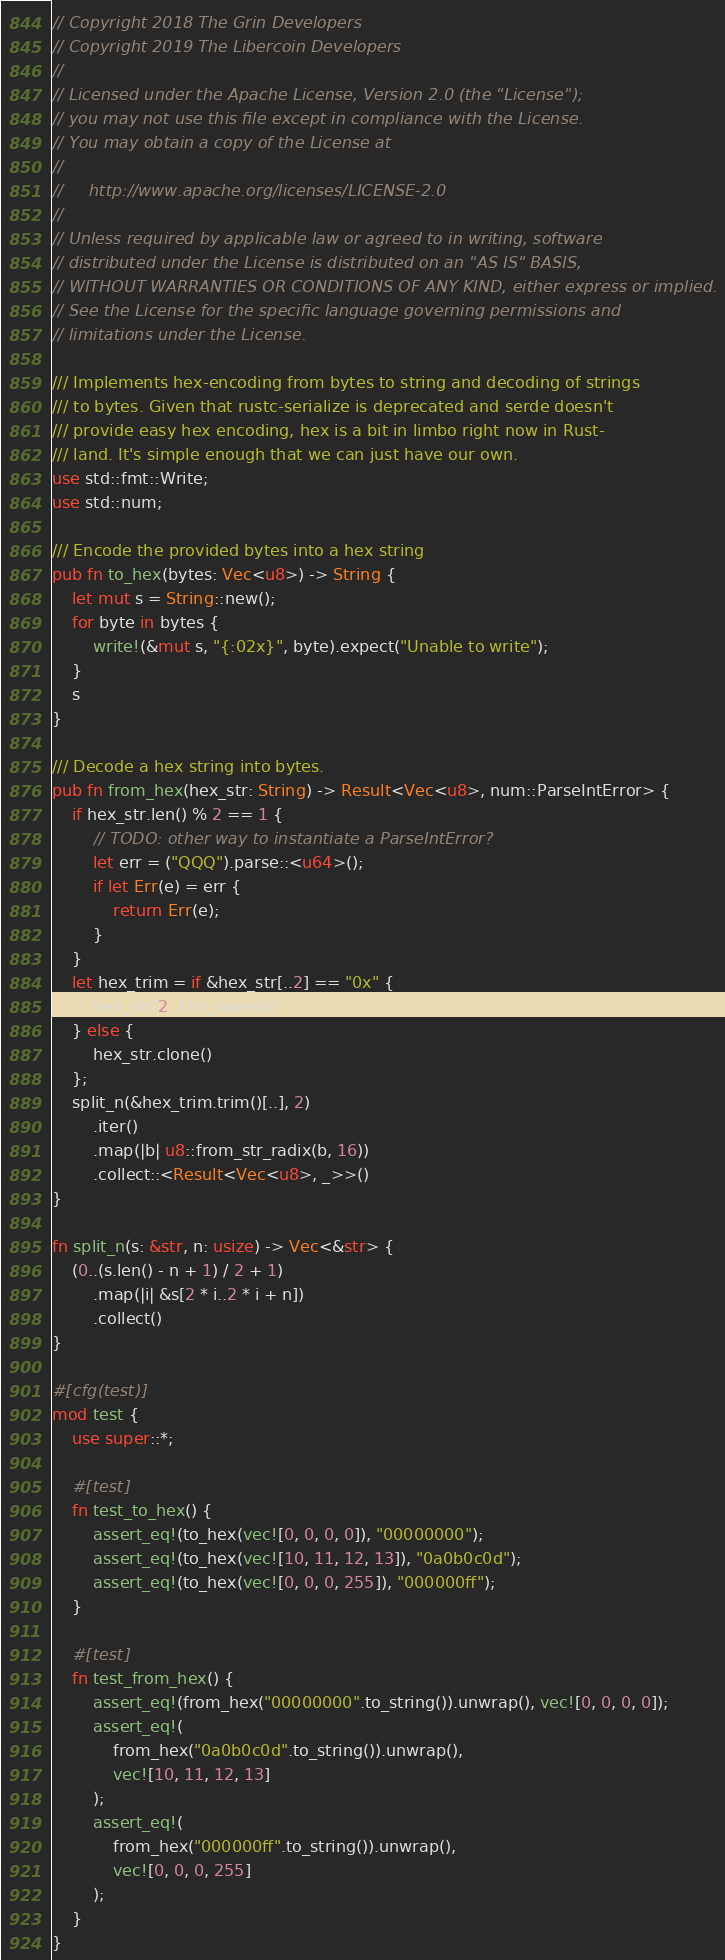<code> <loc_0><loc_0><loc_500><loc_500><_Rust_>// Copyright 2018 The Grin Developers
// Copyright 2019 The Libercoin Developers
//
// Licensed under the Apache License, Version 2.0 (the "License");
// you may not use this file except in compliance with the License.
// You may obtain a copy of the License at
//
//     http://www.apache.org/licenses/LICENSE-2.0
//
// Unless required by applicable law or agreed to in writing, software
// distributed under the License is distributed on an "AS IS" BASIS,
// WITHOUT WARRANTIES OR CONDITIONS OF ANY KIND, either express or implied.
// See the License for the specific language governing permissions and
// limitations under the License.

/// Implements hex-encoding from bytes to string and decoding of strings
/// to bytes. Given that rustc-serialize is deprecated and serde doesn't
/// provide easy hex encoding, hex is a bit in limbo right now in Rust-
/// land. It's simple enough that we can just have our own.
use std::fmt::Write;
use std::num;

/// Encode the provided bytes into a hex string
pub fn to_hex(bytes: Vec<u8>) -> String {
	let mut s = String::new();
	for byte in bytes {
		write!(&mut s, "{:02x}", byte).expect("Unable to write");
	}
	s
}

/// Decode a hex string into bytes.
pub fn from_hex(hex_str: String) -> Result<Vec<u8>, num::ParseIntError> {
	if hex_str.len() % 2 == 1 {
		// TODO: other way to instantiate a ParseIntError?
		let err = ("QQQ").parse::<u64>();
		if let Err(e) = err {
			return Err(e);
		}
	}
	let hex_trim = if &hex_str[..2] == "0x" {
		hex_str[2..].to_owned()
	} else {
		hex_str.clone()
	};
	split_n(&hex_trim.trim()[..], 2)
		.iter()
		.map(|b| u8::from_str_radix(b, 16))
		.collect::<Result<Vec<u8>, _>>()
}

fn split_n(s: &str, n: usize) -> Vec<&str> {
	(0..(s.len() - n + 1) / 2 + 1)
		.map(|i| &s[2 * i..2 * i + n])
		.collect()
}

#[cfg(test)]
mod test {
	use super::*;

	#[test]
	fn test_to_hex() {
		assert_eq!(to_hex(vec![0, 0, 0, 0]), "00000000");
		assert_eq!(to_hex(vec![10, 11, 12, 13]), "0a0b0c0d");
		assert_eq!(to_hex(vec![0, 0, 0, 255]), "000000ff");
	}

	#[test]
	fn test_from_hex() {
		assert_eq!(from_hex("00000000".to_string()).unwrap(), vec![0, 0, 0, 0]);
		assert_eq!(
			from_hex("0a0b0c0d".to_string()).unwrap(),
			vec![10, 11, 12, 13]
		);
		assert_eq!(
			from_hex("000000ff".to_string()).unwrap(),
			vec![0, 0, 0, 255]
		);
	}
}
</code> 